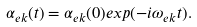Convert formula to latex. <formula><loc_0><loc_0><loc_500><loc_500>\alpha _ { e { k } } ( t ) = \alpha _ { e { k } } ( 0 ) e x p ( - i \omega _ { e { k } } t ) .</formula> 